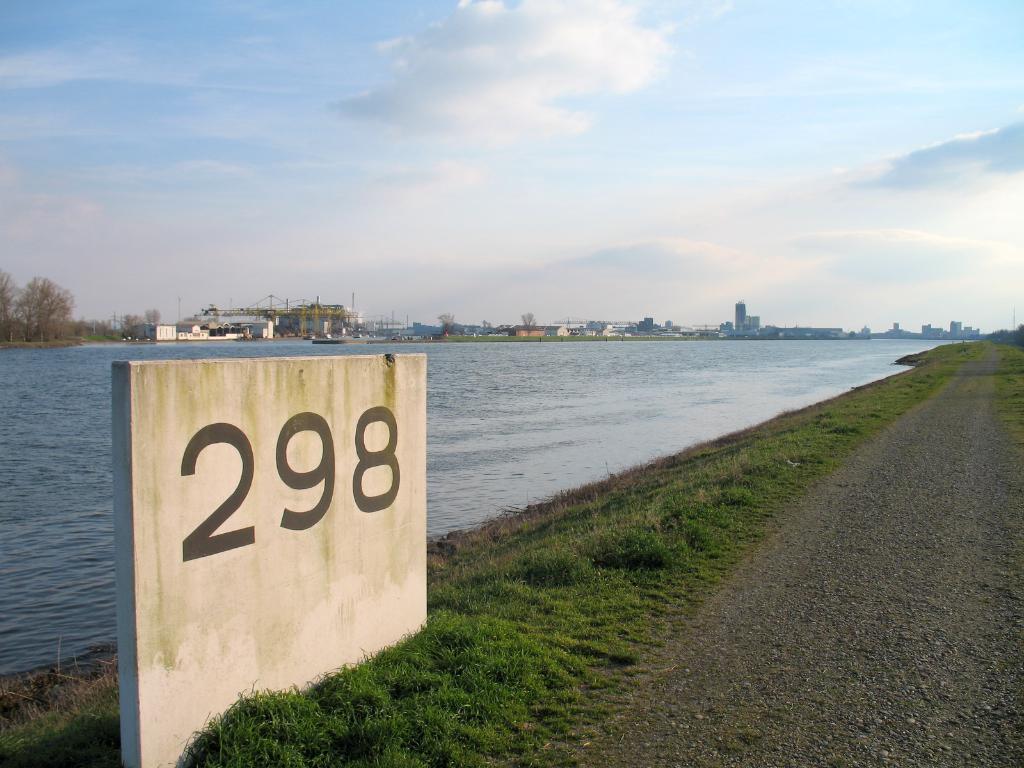How would you summarize this image in a sentence or two? On the right side of the image we can see grass and road. On the left side of the image we can see buildings, water, name board and trees. In the background we can see buildings, trees, water, sky and clouds. 